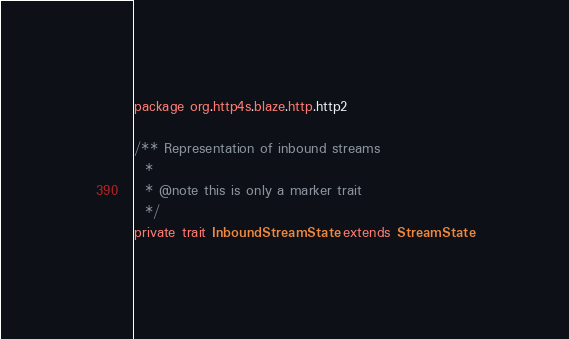Convert code to text. <code><loc_0><loc_0><loc_500><loc_500><_Scala_>package org.http4s.blaze.http.http2

/** Representation of inbound streams
  *
  * @note this is only a marker trait
  */
private trait InboundStreamState extends StreamState
</code> 